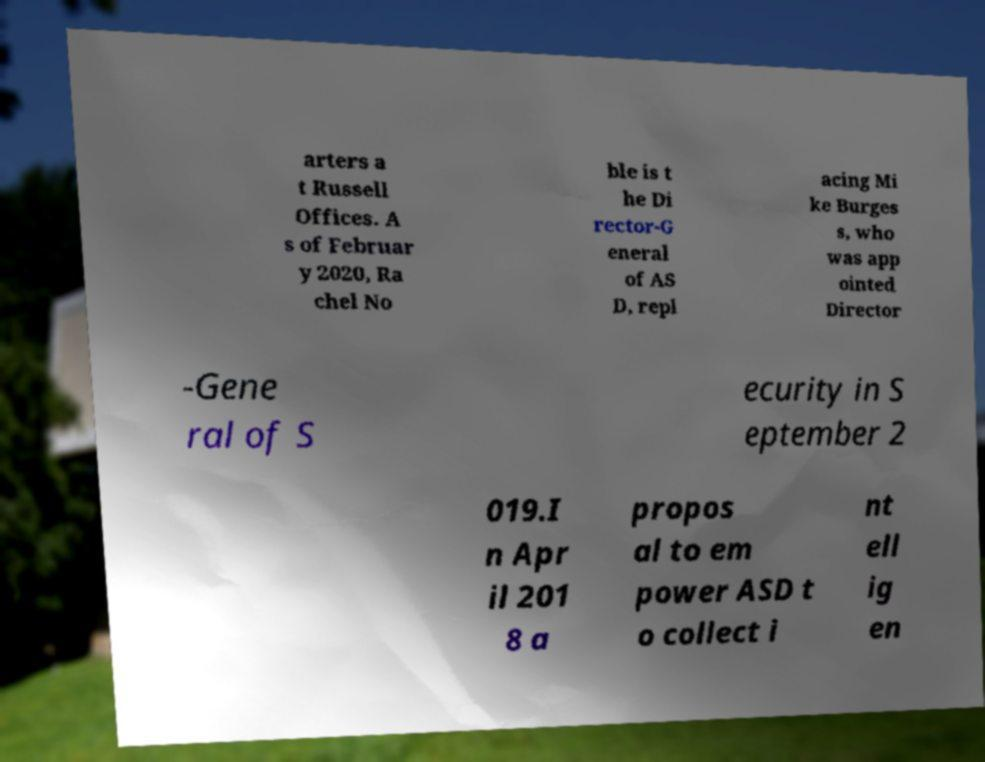Please read and relay the text visible in this image. What does it say? arters a t Russell Offices. A s of Februar y 2020, Ra chel No ble is t he Di rector-G eneral of AS D, repl acing Mi ke Burges s, who was app ointed Director -Gene ral of S ecurity in S eptember 2 019.I n Apr il 201 8 a propos al to em power ASD t o collect i nt ell ig en 